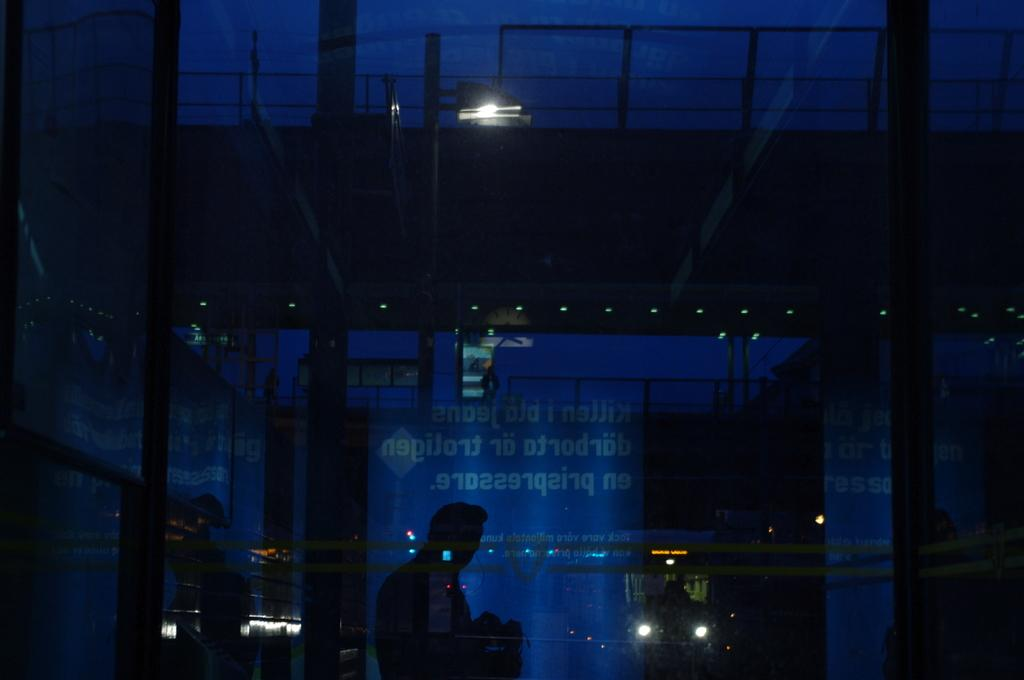What object is present in the image that can hold a liquid? There is a glass in the image that can hold a liquid. Who or what is behind the glass in the image? There is a person standing behind the glass in the image. What can be read or seen on the banner in the image? There is a banner with text in the image. What type of illumination is visible in the image? There are lights visible in the image. Can you solve the riddle written on the zebra at the airport in the image? There is no riddle, zebra, or airport present in the image. 